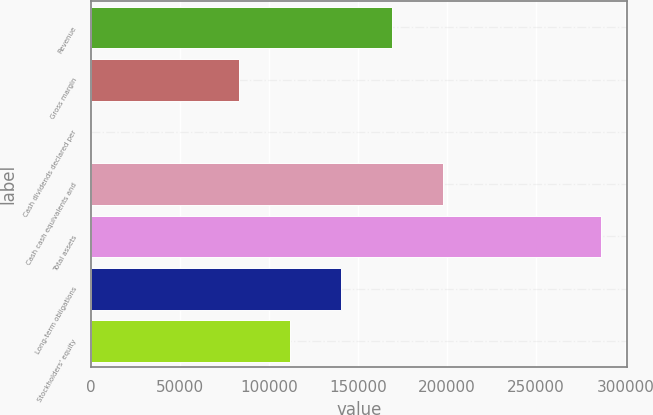<chart> <loc_0><loc_0><loc_500><loc_500><bar_chart><fcel>Revenue<fcel>Gross margin<fcel>Cash dividends declared per<fcel>Cash cash equivalents and<fcel>Total assets<fcel>Long-term obligations<fcel>Stockholders' equity<nl><fcel>168899<fcel>82933<fcel>1.84<fcel>197555<fcel>286556<fcel>140244<fcel>111588<nl></chart> 